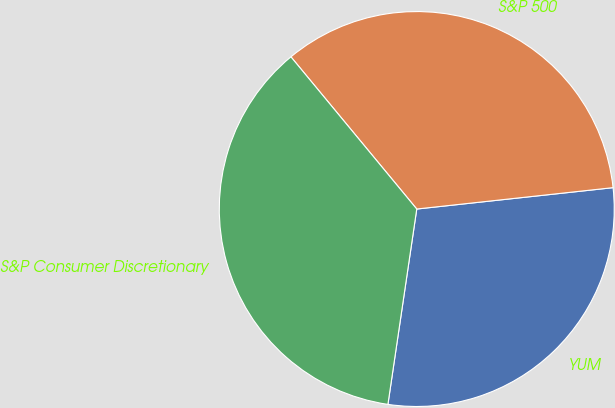Convert chart. <chart><loc_0><loc_0><loc_500><loc_500><pie_chart><fcel>YUM<fcel>S&P 500<fcel>S&P Consumer Discretionary<nl><fcel>29.06%<fcel>34.27%<fcel>36.67%<nl></chart> 